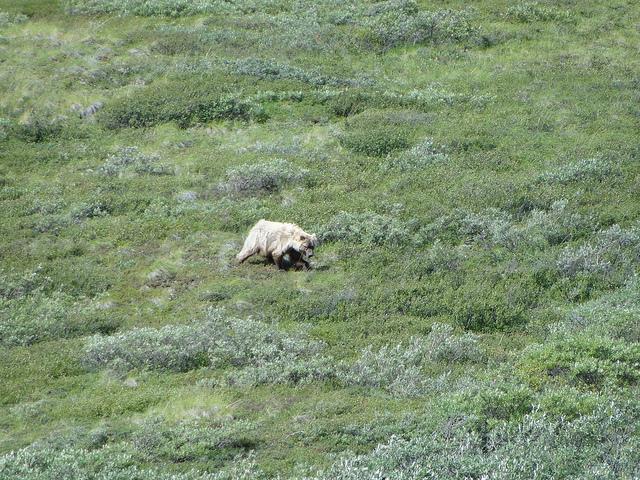Are there any rock in the photo?
Be succinct. No. What animals are grazing?
Keep it brief. Bear. Are the sheep standing on a hill?
Be succinct. Yes. Is the bear real?
Answer briefly. Yes. Does this animal eat meat?
Be succinct. Yes. Is this picture blurry?
Write a very short answer. No. Are there trees in this image?
Give a very brief answer. No. What type of animal is this?
Quick response, please. Bear. Can this animal fly?
Be succinct. No. Is this a popular gossiping area for cows?
Answer briefly. No. Is it in water?
Answer briefly. No. What color is the dog?
Concise answer only. White. How many cows are shown?
Write a very short answer. 0. Is the ram chasing the dog?
Short answer required. No. 